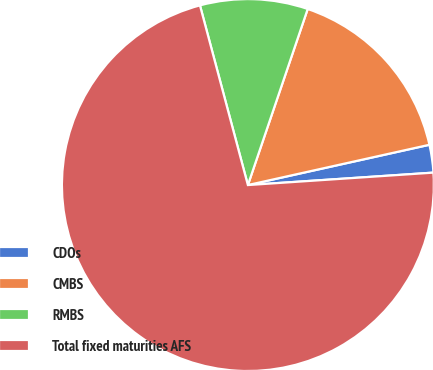Convert chart. <chart><loc_0><loc_0><loc_500><loc_500><pie_chart><fcel>CDOs<fcel>CMBS<fcel>RMBS<fcel>Total fixed maturities AFS<nl><fcel>2.41%<fcel>16.31%<fcel>9.36%<fcel>71.91%<nl></chart> 